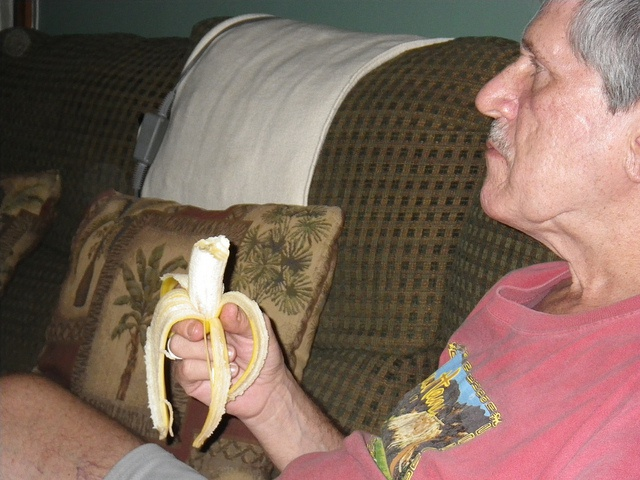Describe the objects in this image and their specific colors. I can see couch in black, gray, and darkgray tones, people in black, lightpink, gray, salmon, and darkgray tones, and banana in black, ivory, and tan tones in this image. 